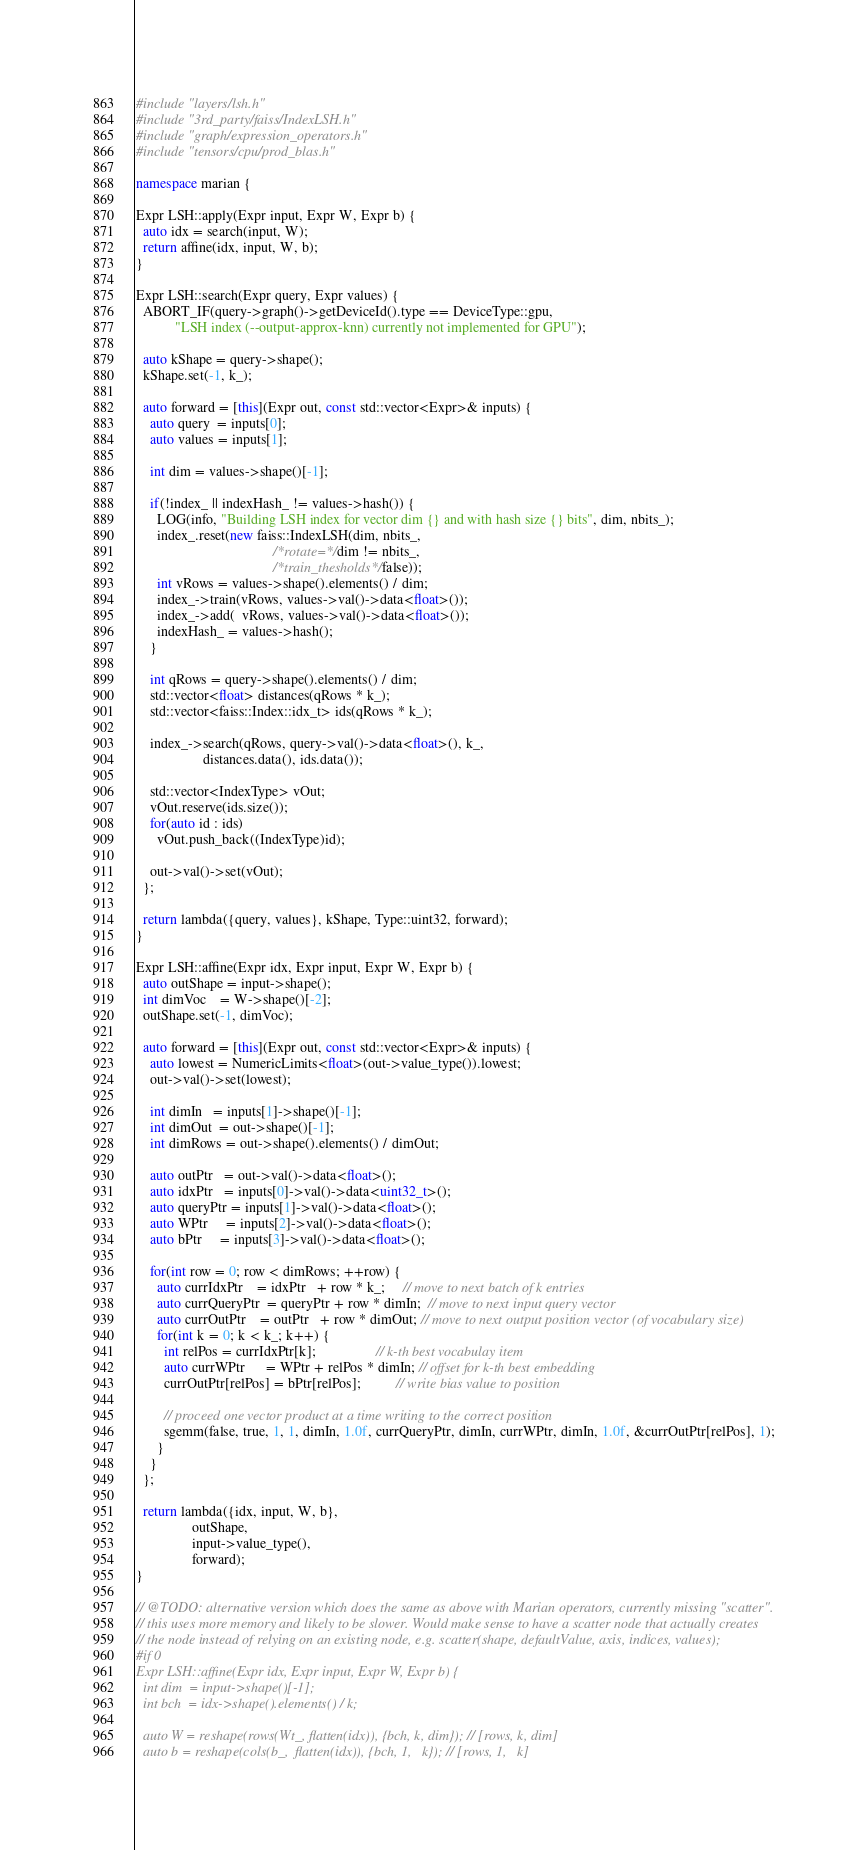<code> <loc_0><loc_0><loc_500><loc_500><_C++_>#include "layers/lsh.h"
#include "3rd_party/faiss/IndexLSH.h"
#include "graph/expression_operators.h"
#include "tensors/cpu/prod_blas.h"

namespace marian {

Expr LSH::apply(Expr input, Expr W, Expr b) {
  auto idx = search(input, W);
  return affine(idx, input, W, b);
}

Expr LSH::search(Expr query, Expr values) {
  ABORT_IF(query->graph()->getDeviceId().type == DeviceType::gpu,
           "LSH index (--output-approx-knn) currently not implemented for GPU");

  auto kShape = query->shape();
  kShape.set(-1, k_);

  auto forward = [this](Expr out, const std::vector<Expr>& inputs) {
    auto query  = inputs[0];
    auto values = inputs[1];

    int dim = values->shape()[-1];

    if(!index_ || indexHash_ != values->hash()) {
      LOG(info, "Building LSH index for vector dim {} and with hash size {} bits", dim, nbits_);
      index_.reset(new faiss::IndexLSH(dim, nbits_, 
                                       /*rotate=*/dim != nbits_, 
                                       /*train_thesholds*/false));
      int vRows = values->shape().elements() / dim;
      index_->train(vRows, values->val()->data<float>());
      index_->add(  vRows, values->val()->data<float>());
      indexHash_ = values->hash();
    }

    int qRows = query->shape().elements() / dim;
    std::vector<float> distances(qRows * k_);
    std::vector<faiss::Index::idx_t> ids(qRows * k_);

    index_->search(qRows, query->val()->data<float>(), k_,
                   distances.data(), ids.data());
    
    std::vector<IndexType> vOut;
    vOut.reserve(ids.size());
    for(auto id : ids)
      vOut.push_back((IndexType)id);

    out->val()->set(vOut);
  };

  return lambda({query, values}, kShape, Type::uint32, forward);
}

Expr LSH::affine(Expr idx, Expr input, Expr W, Expr b) {
  auto outShape = input->shape();
  int dimVoc    = W->shape()[-2];
  outShape.set(-1, dimVoc);

  auto forward = [this](Expr out, const std::vector<Expr>& inputs) {
    auto lowest = NumericLimits<float>(out->value_type()).lowest;
    out->val()->set(lowest);

    int dimIn   = inputs[1]->shape()[-1];
    int dimOut  = out->shape()[-1];
    int dimRows = out->shape().elements() / dimOut;
    
    auto outPtr   = out->val()->data<float>();
    auto idxPtr   = inputs[0]->val()->data<uint32_t>();
    auto queryPtr = inputs[1]->val()->data<float>();
    auto WPtr     = inputs[2]->val()->data<float>();
    auto bPtr     = inputs[3]->val()->data<float>();

    for(int row = 0; row < dimRows; ++row) {
      auto currIdxPtr    = idxPtr   + row * k_;     // move to next batch of k entries
      auto currQueryPtr  = queryPtr + row * dimIn;  // move to next input query vector
      auto currOutPtr    = outPtr   + row * dimOut; // move to next output position vector (of vocabulary size)
      for(int k = 0; k < k_; k++) {
        int relPos = currIdxPtr[k];                 // k-th best vocabulay item
        auto currWPtr      = WPtr + relPos * dimIn; // offset for k-th best embedding
        currOutPtr[relPos] = bPtr[relPos];          // write bias value to position
        
        // proceed one vector product at a time writing to the correct position
        sgemm(false, true, 1, 1, dimIn, 1.0f, currQueryPtr, dimIn, currWPtr, dimIn, 1.0f, &currOutPtr[relPos], 1);
      }
    }
  };

  return lambda({idx, input, W, b}, 
                outShape,
                input->value_type(),
                forward);
}

// @TODO: alternative version which does the same as above with Marian operators, currently missing "scatter".
// this uses more memory and likely to be slower. Would make sense to have a scatter node that actually creates
// the node instead of relying on an existing node, e.g. scatter(shape, defaultValue, axis, indices, values);
#if 0 
Expr LSH::affine(Expr idx, Expr input, Expr W, Expr b) {
  int dim  = input->shape()[-1];
  int bch  = idx->shape().elements() / k;

  auto W = reshape(rows(Wt_, flatten(idx)), {bch, k, dim}); // [rows, k, dim]
  auto b = reshape(cols(b_,  flatten(idx)), {bch, 1,   k}); // [rows, 1,   k]
</code> 